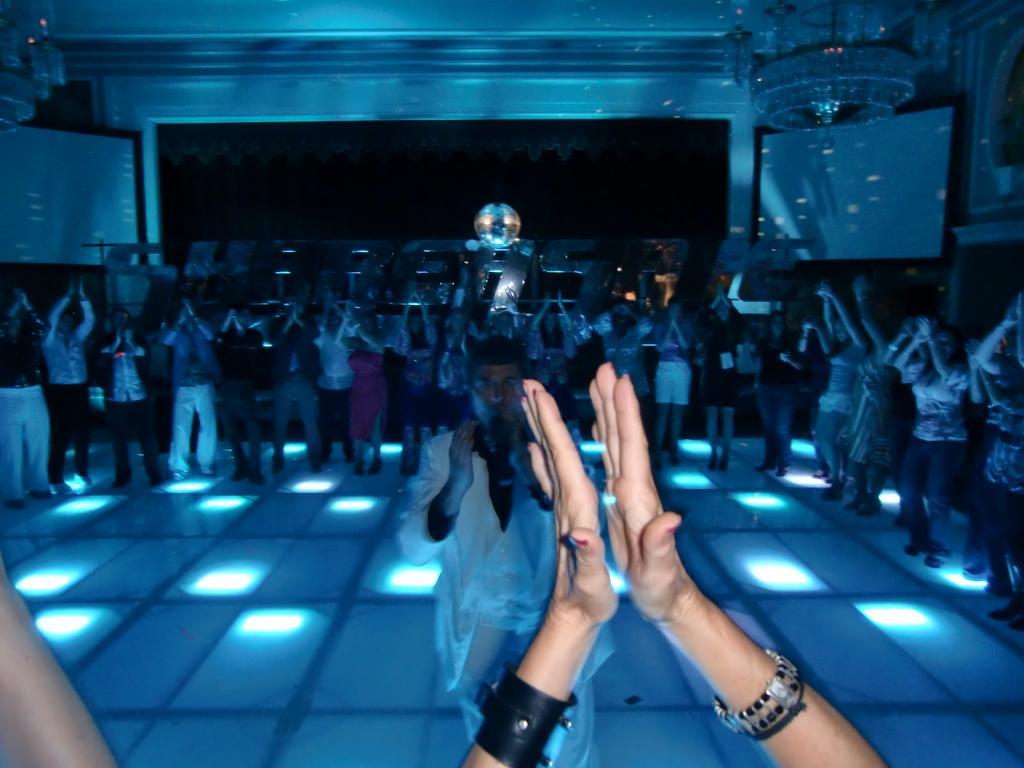Could you give a brief overview of what you see in this image? In this image at the bottom there is one person's hands are visible, and the person is clapping. And in the background there are group of people who are clapping, and one person is holding a mike and talking. At the bottom there is floor and in the background there are some boards, chandeliers and some objects. In the center of the image there is text and some lights. 